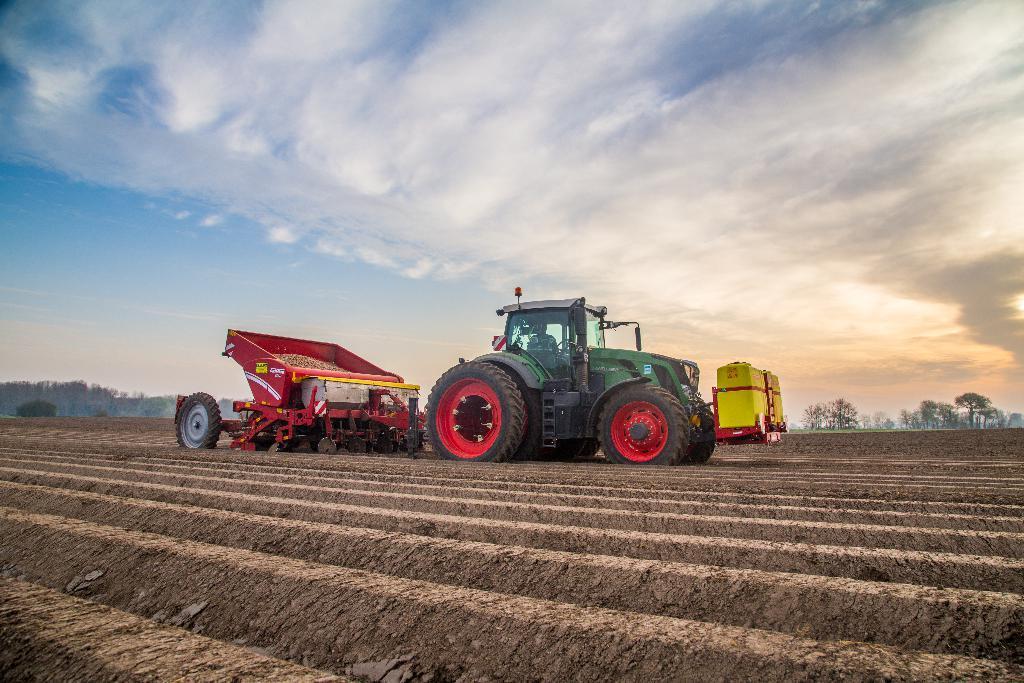In one or two sentences, can you explain what this image depicts? In this image, I can see a tractor with the truck, which is on a field. In the background, there are trees and the sky. 